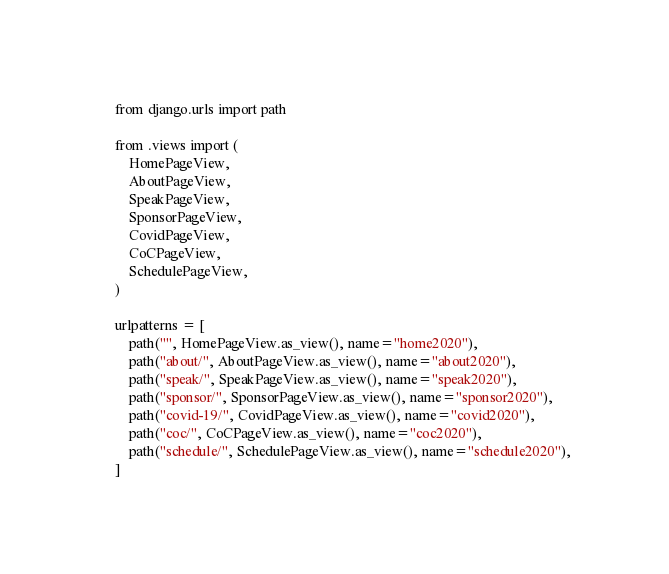<code> <loc_0><loc_0><loc_500><loc_500><_Python_>from django.urls import path

from .views import (
    HomePageView,
    AboutPageView,
    SpeakPageView,
    SponsorPageView,
    CovidPageView,
    CoCPageView,
    SchedulePageView,
)

urlpatterns = [
    path("", HomePageView.as_view(), name="home2020"),
    path("about/", AboutPageView.as_view(), name="about2020"),
    path("speak/", SpeakPageView.as_view(), name="speak2020"),
    path("sponsor/", SponsorPageView.as_view(), name="sponsor2020"),
    path("covid-19/", CovidPageView.as_view(), name="covid2020"),
    path("coc/", CoCPageView.as_view(), name="coc2020"),
    path("schedule/", SchedulePageView.as_view(), name="schedule2020"),
]
</code> 